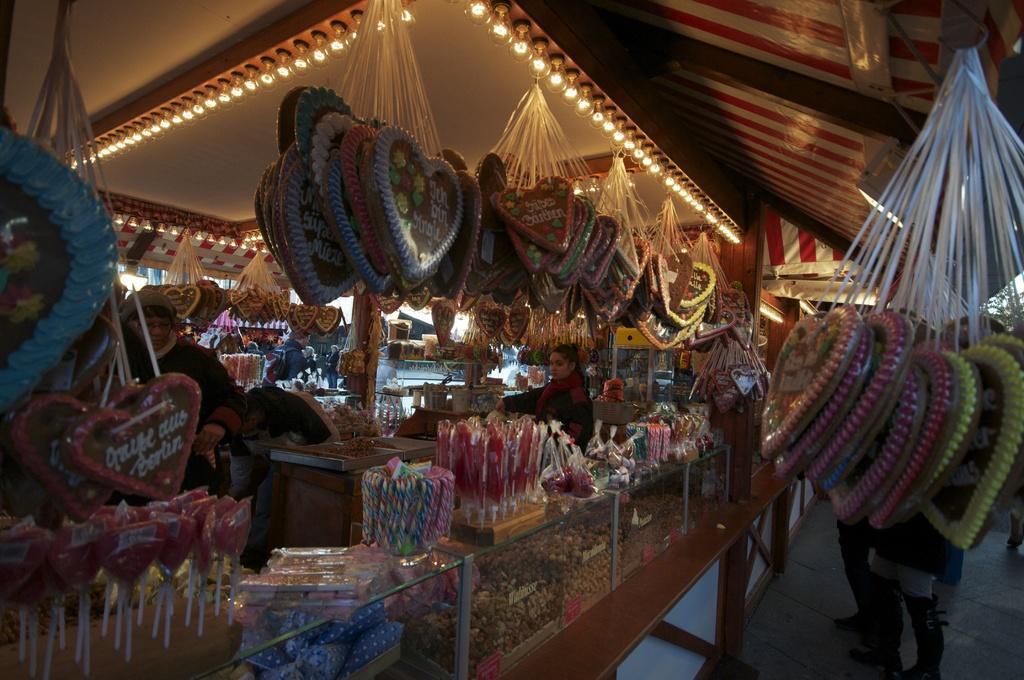How would you summarize this image in a sentence or two? In this image I can see food stalls. There are candies, food items in glass boxes , lights, there are few people and there are some other objects. 